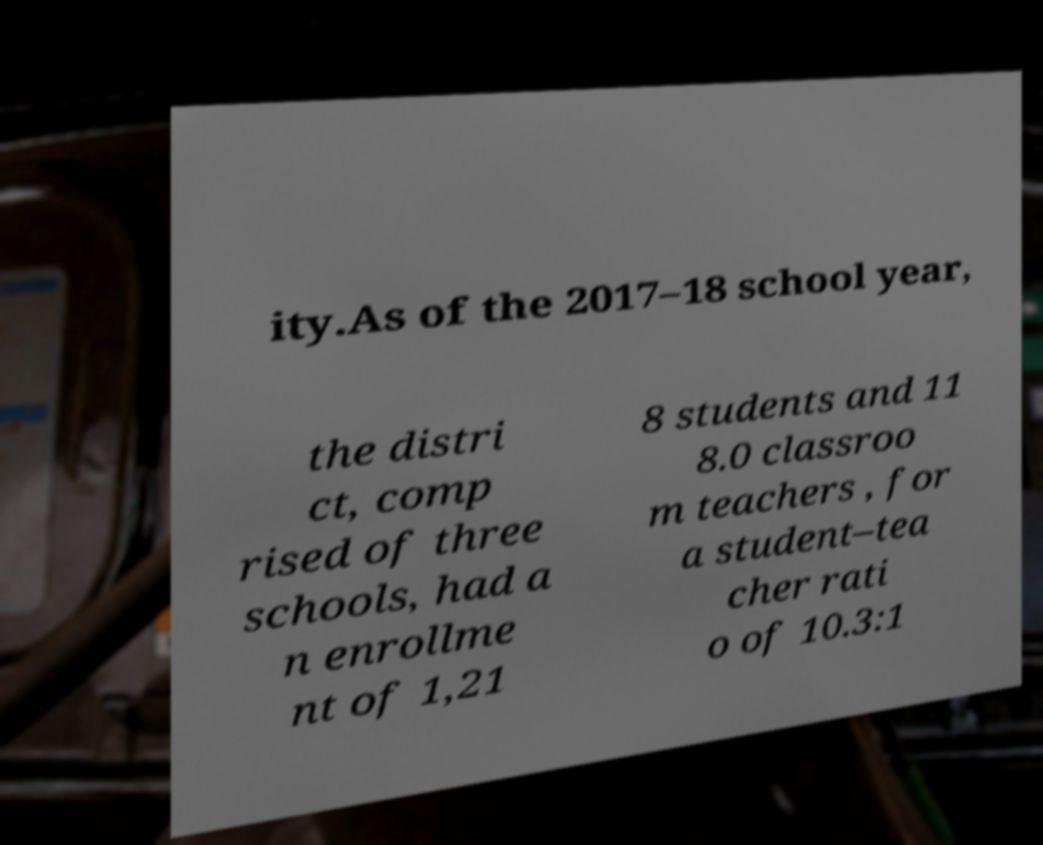Could you assist in decoding the text presented in this image and type it out clearly? ity.As of the 2017–18 school year, the distri ct, comp rised of three schools, had a n enrollme nt of 1,21 8 students and 11 8.0 classroo m teachers , for a student–tea cher rati o of 10.3:1 